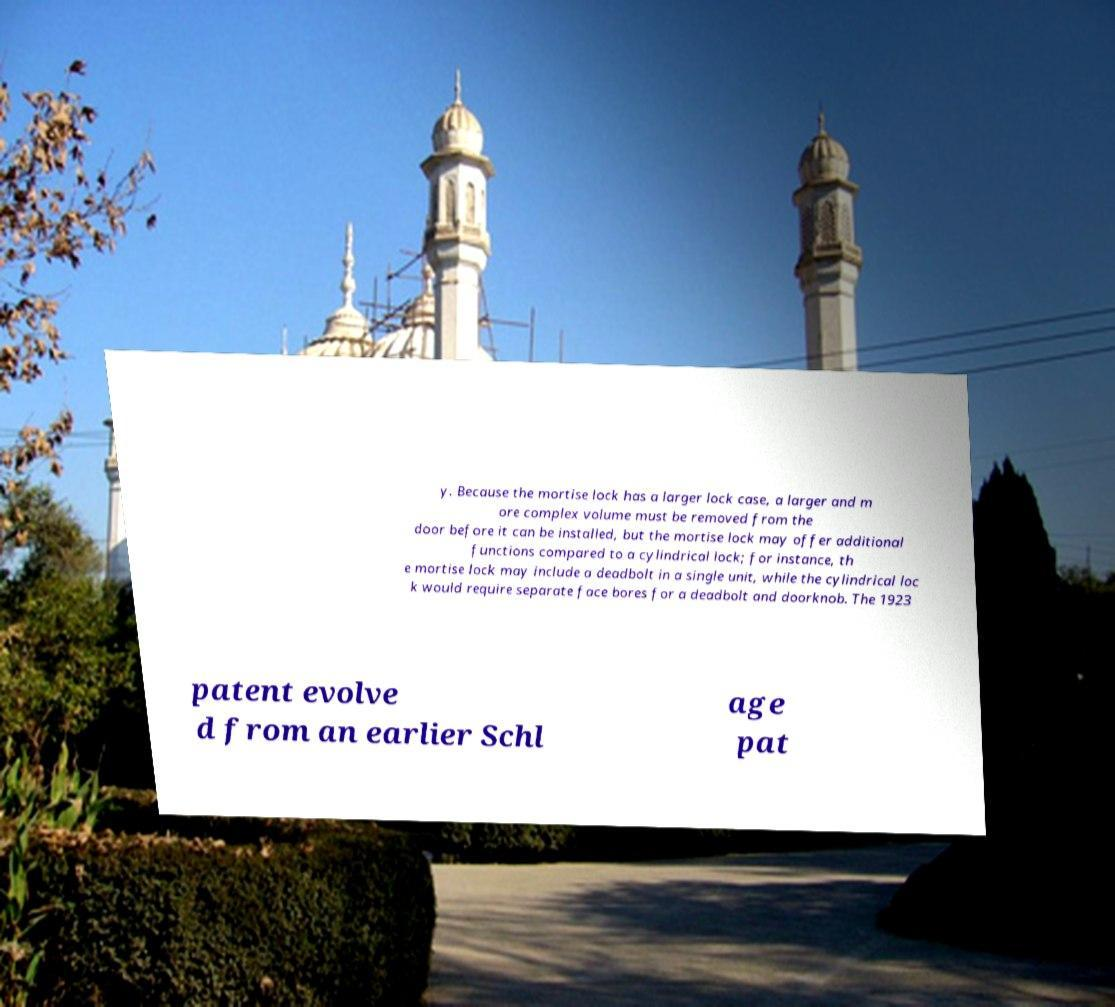For documentation purposes, I need the text within this image transcribed. Could you provide that? y. Because the mortise lock has a larger lock case, a larger and m ore complex volume must be removed from the door before it can be installed, but the mortise lock may offer additional functions compared to a cylindrical lock; for instance, th e mortise lock may include a deadbolt in a single unit, while the cylindrical loc k would require separate face bores for a deadbolt and doorknob. The 1923 patent evolve d from an earlier Schl age pat 